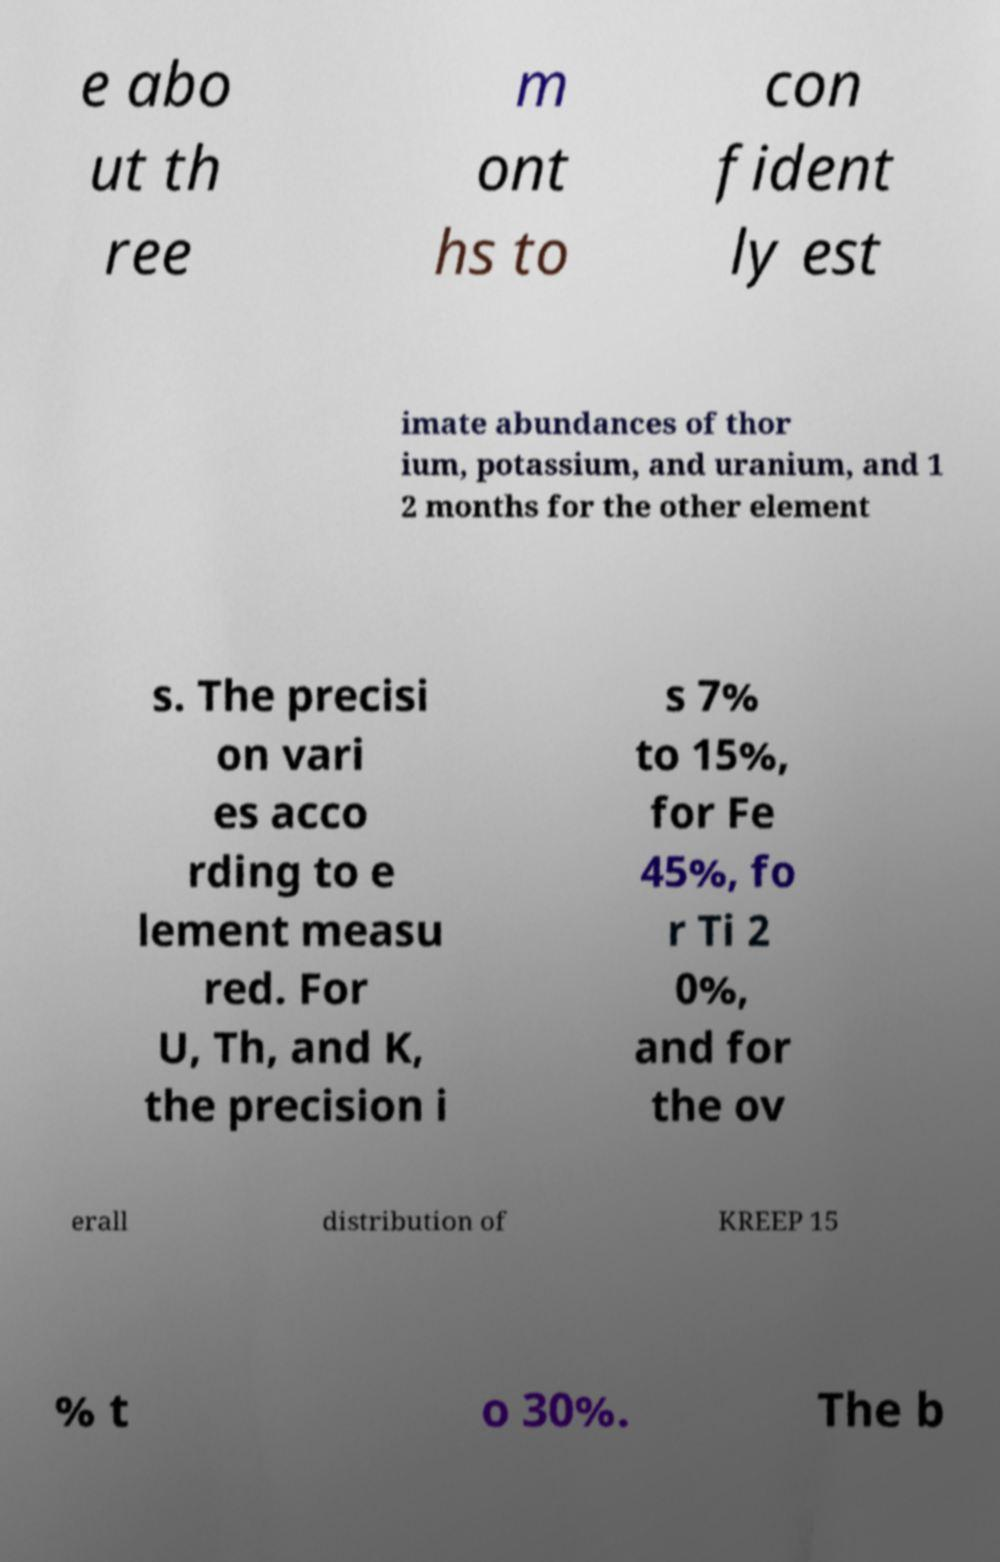I need the written content from this picture converted into text. Can you do that? e abo ut th ree m ont hs to con fident ly est imate abundances of thor ium, potassium, and uranium, and 1 2 months for the other element s. The precisi on vari es acco rding to e lement measu red. For U, Th, and K, the precision i s 7% to 15%, for Fe 45%, fo r Ti 2 0%, and for the ov erall distribution of KREEP 15 % t o 30%. The b 